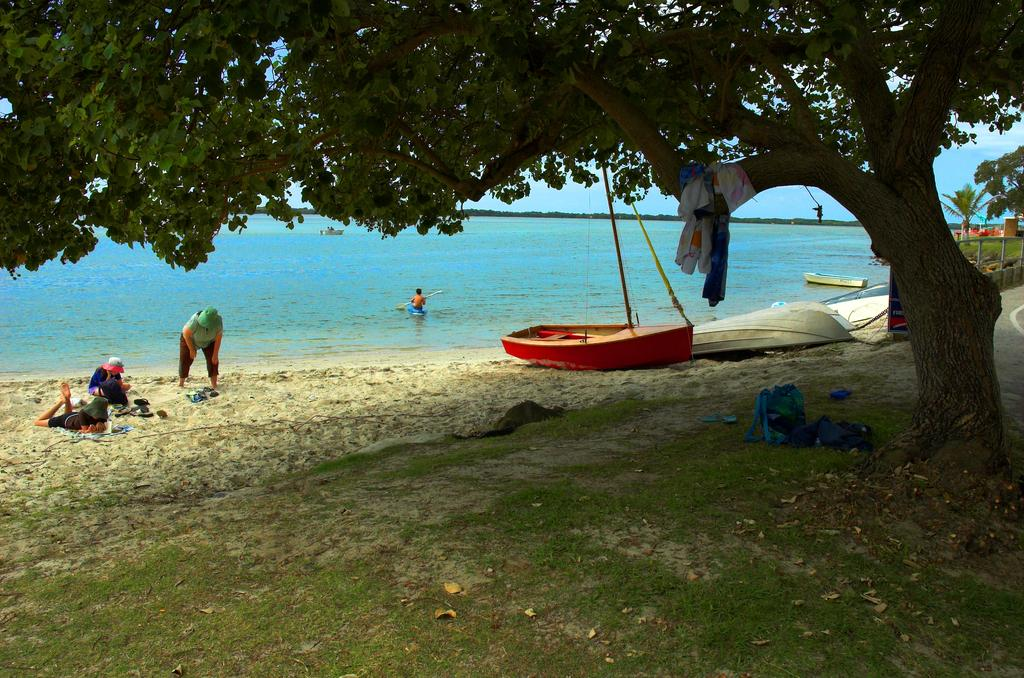What type of plant can be seen in the image? There is a tree in the image. Where are the boats located in the image? The boats are in the right corner of the image. What can be seen in the left corner of the image? There are people in the left corner of the image. What is visible in the background of the image? There is water visible in the background of the image. Can you tell me how many owls are perched on the tree in the image? There are no owls present in the image; it features a tree, boats, people, and water. What type of light source is illuminating the scene in the image? The image does not provide information about a light source; it only shows a tree, boats, people, and water. 